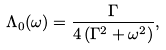Convert formula to latex. <formula><loc_0><loc_0><loc_500><loc_500>\Lambda _ { 0 } ( \omega ) = \frac { \Gamma } { 4 \left ( \Gamma ^ { 2 } + \omega ^ { 2 } \right ) } ,</formula> 